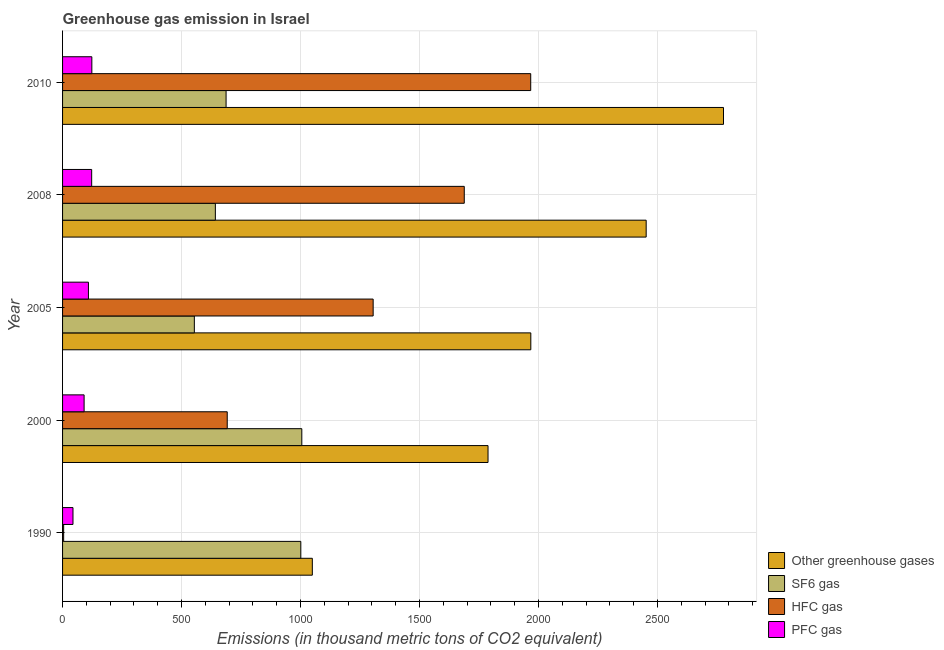Are the number of bars per tick equal to the number of legend labels?
Make the answer very short. Yes. How many bars are there on the 3rd tick from the bottom?
Give a very brief answer. 4. What is the label of the 3rd group of bars from the top?
Offer a very short reply. 2005. In how many cases, is the number of bars for a given year not equal to the number of legend labels?
Keep it short and to the point. 0. What is the emission of pfc gas in 2005?
Offer a terse response. 108.7. Across all years, what is the maximum emission of pfc gas?
Your answer should be very brief. 123. Across all years, what is the minimum emission of sf6 gas?
Your response must be concise. 553.7. What is the total emission of greenhouse gases in the graph?
Your answer should be compact. 1.00e+04. What is the difference between the emission of greenhouse gases in 2000 and that in 2010?
Provide a succinct answer. -989.4. What is the difference between the emission of pfc gas in 2010 and the emission of sf6 gas in 2000?
Give a very brief answer. -882.2. What is the average emission of pfc gas per year?
Ensure brevity in your answer.  97.66. In the year 2008, what is the difference between the emission of pfc gas and emission of hfc gas?
Make the answer very short. -1565.5. What is the ratio of the emission of greenhouse gases in 2005 to that in 2010?
Your answer should be very brief. 0.71. Is the emission of pfc gas in 2005 less than that in 2010?
Keep it short and to the point. Yes. Is the difference between the emission of greenhouse gases in 2000 and 2005 greater than the difference between the emission of pfc gas in 2000 and 2005?
Provide a succinct answer. No. What is the difference between the highest and the second highest emission of hfc gas?
Keep it short and to the point. 279.2. What is the difference between the highest and the lowest emission of greenhouse gases?
Give a very brief answer. 1727.6. Is the sum of the emission of hfc gas in 2000 and 2005 greater than the maximum emission of sf6 gas across all years?
Give a very brief answer. Yes. What does the 3rd bar from the top in 2008 represents?
Offer a terse response. SF6 gas. What does the 4th bar from the bottom in 2010 represents?
Give a very brief answer. PFC gas. Is it the case that in every year, the sum of the emission of greenhouse gases and emission of sf6 gas is greater than the emission of hfc gas?
Provide a short and direct response. Yes. Are all the bars in the graph horizontal?
Provide a short and direct response. Yes. What is the difference between two consecutive major ticks on the X-axis?
Give a very brief answer. 500. Does the graph contain any zero values?
Provide a succinct answer. No. Where does the legend appear in the graph?
Provide a short and direct response. Bottom right. What is the title of the graph?
Your answer should be compact. Greenhouse gas emission in Israel. What is the label or title of the X-axis?
Make the answer very short. Emissions (in thousand metric tons of CO2 equivalent). What is the Emissions (in thousand metric tons of CO2 equivalent) of Other greenhouse gases in 1990?
Offer a very short reply. 1049.4. What is the Emissions (in thousand metric tons of CO2 equivalent) in SF6 gas in 1990?
Provide a succinct answer. 1001. What is the Emissions (in thousand metric tons of CO2 equivalent) in PFC gas in 1990?
Ensure brevity in your answer.  43.8. What is the Emissions (in thousand metric tons of CO2 equivalent) of Other greenhouse gases in 2000?
Keep it short and to the point. 1787.6. What is the Emissions (in thousand metric tons of CO2 equivalent) in SF6 gas in 2000?
Provide a short and direct response. 1005.2. What is the Emissions (in thousand metric tons of CO2 equivalent) of HFC gas in 2000?
Your answer should be very brief. 691.9. What is the Emissions (in thousand metric tons of CO2 equivalent) of PFC gas in 2000?
Ensure brevity in your answer.  90.5. What is the Emissions (in thousand metric tons of CO2 equivalent) of Other greenhouse gases in 2005?
Make the answer very short. 1967.4. What is the Emissions (in thousand metric tons of CO2 equivalent) of SF6 gas in 2005?
Your answer should be compact. 553.7. What is the Emissions (in thousand metric tons of CO2 equivalent) of HFC gas in 2005?
Provide a short and direct response. 1305. What is the Emissions (in thousand metric tons of CO2 equivalent) of PFC gas in 2005?
Your response must be concise. 108.7. What is the Emissions (in thousand metric tons of CO2 equivalent) of Other greenhouse gases in 2008?
Your answer should be very brief. 2452.1. What is the Emissions (in thousand metric tons of CO2 equivalent) in SF6 gas in 2008?
Provide a succinct answer. 642. What is the Emissions (in thousand metric tons of CO2 equivalent) of HFC gas in 2008?
Offer a terse response. 1687.8. What is the Emissions (in thousand metric tons of CO2 equivalent) in PFC gas in 2008?
Provide a short and direct response. 122.3. What is the Emissions (in thousand metric tons of CO2 equivalent) in Other greenhouse gases in 2010?
Offer a terse response. 2777. What is the Emissions (in thousand metric tons of CO2 equivalent) of SF6 gas in 2010?
Ensure brevity in your answer.  687. What is the Emissions (in thousand metric tons of CO2 equivalent) of HFC gas in 2010?
Your response must be concise. 1967. What is the Emissions (in thousand metric tons of CO2 equivalent) in PFC gas in 2010?
Provide a short and direct response. 123. Across all years, what is the maximum Emissions (in thousand metric tons of CO2 equivalent) in Other greenhouse gases?
Offer a terse response. 2777. Across all years, what is the maximum Emissions (in thousand metric tons of CO2 equivalent) of SF6 gas?
Make the answer very short. 1005.2. Across all years, what is the maximum Emissions (in thousand metric tons of CO2 equivalent) in HFC gas?
Offer a very short reply. 1967. Across all years, what is the maximum Emissions (in thousand metric tons of CO2 equivalent) of PFC gas?
Provide a succinct answer. 123. Across all years, what is the minimum Emissions (in thousand metric tons of CO2 equivalent) in Other greenhouse gases?
Your answer should be very brief. 1049.4. Across all years, what is the minimum Emissions (in thousand metric tons of CO2 equivalent) in SF6 gas?
Provide a succinct answer. 553.7. Across all years, what is the minimum Emissions (in thousand metric tons of CO2 equivalent) in HFC gas?
Your response must be concise. 4.6. Across all years, what is the minimum Emissions (in thousand metric tons of CO2 equivalent) of PFC gas?
Your response must be concise. 43.8. What is the total Emissions (in thousand metric tons of CO2 equivalent) in Other greenhouse gases in the graph?
Keep it short and to the point. 1.00e+04. What is the total Emissions (in thousand metric tons of CO2 equivalent) of SF6 gas in the graph?
Offer a very short reply. 3888.9. What is the total Emissions (in thousand metric tons of CO2 equivalent) of HFC gas in the graph?
Your answer should be very brief. 5656.3. What is the total Emissions (in thousand metric tons of CO2 equivalent) of PFC gas in the graph?
Your answer should be compact. 488.3. What is the difference between the Emissions (in thousand metric tons of CO2 equivalent) in Other greenhouse gases in 1990 and that in 2000?
Offer a very short reply. -738.2. What is the difference between the Emissions (in thousand metric tons of CO2 equivalent) of SF6 gas in 1990 and that in 2000?
Your response must be concise. -4.2. What is the difference between the Emissions (in thousand metric tons of CO2 equivalent) of HFC gas in 1990 and that in 2000?
Your response must be concise. -687.3. What is the difference between the Emissions (in thousand metric tons of CO2 equivalent) of PFC gas in 1990 and that in 2000?
Provide a succinct answer. -46.7. What is the difference between the Emissions (in thousand metric tons of CO2 equivalent) in Other greenhouse gases in 1990 and that in 2005?
Your response must be concise. -918. What is the difference between the Emissions (in thousand metric tons of CO2 equivalent) in SF6 gas in 1990 and that in 2005?
Offer a terse response. 447.3. What is the difference between the Emissions (in thousand metric tons of CO2 equivalent) in HFC gas in 1990 and that in 2005?
Provide a succinct answer. -1300.4. What is the difference between the Emissions (in thousand metric tons of CO2 equivalent) in PFC gas in 1990 and that in 2005?
Offer a very short reply. -64.9. What is the difference between the Emissions (in thousand metric tons of CO2 equivalent) in Other greenhouse gases in 1990 and that in 2008?
Offer a terse response. -1402.7. What is the difference between the Emissions (in thousand metric tons of CO2 equivalent) of SF6 gas in 1990 and that in 2008?
Provide a short and direct response. 359. What is the difference between the Emissions (in thousand metric tons of CO2 equivalent) in HFC gas in 1990 and that in 2008?
Make the answer very short. -1683.2. What is the difference between the Emissions (in thousand metric tons of CO2 equivalent) of PFC gas in 1990 and that in 2008?
Ensure brevity in your answer.  -78.5. What is the difference between the Emissions (in thousand metric tons of CO2 equivalent) in Other greenhouse gases in 1990 and that in 2010?
Your answer should be very brief. -1727.6. What is the difference between the Emissions (in thousand metric tons of CO2 equivalent) in SF6 gas in 1990 and that in 2010?
Ensure brevity in your answer.  314. What is the difference between the Emissions (in thousand metric tons of CO2 equivalent) of HFC gas in 1990 and that in 2010?
Give a very brief answer. -1962.4. What is the difference between the Emissions (in thousand metric tons of CO2 equivalent) of PFC gas in 1990 and that in 2010?
Your answer should be very brief. -79.2. What is the difference between the Emissions (in thousand metric tons of CO2 equivalent) in Other greenhouse gases in 2000 and that in 2005?
Give a very brief answer. -179.8. What is the difference between the Emissions (in thousand metric tons of CO2 equivalent) of SF6 gas in 2000 and that in 2005?
Your answer should be very brief. 451.5. What is the difference between the Emissions (in thousand metric tons of CO2 equivalent) of HFC gas in 2000 and that in 2005?
Provide a succinct answer. -613.1. What is the difference between the Emissions (in thousand metric tons of CO2 equivalent) of PFC gas in 2000 and that in 2005?
Your answer should be compact. -18.2. What is the difference between the Emissions (in thousand metric tons of CO2 equivalent) of Other greenhouse gases in 2000 and that in 2008?
Offer a terse response. -664.5. What is the difference between the Emissions (in thousand metric tons of CO2 equivalent) of SF6 gas in 2000 and that in 2008?
Give a very brief answer. 363.2. What is the difference between the Emissions (in thousand metric tons of CO2 equivalent) in HFC gas in 2000 and that in 2008?
Ensure brevity in your answer.  -995.9. What is the difference between the Emissions (in thousand metric tons of CO2 equivalent) of PFC gas in 2000 and that in 2008?
Your answer should be very brief. -31.8. What is the difference between the Emissions (in thousand metric tons of CO2 equivalent) of Other greenhouse gases in 2000 and that in 2010?
Keep it short and to the point. -989.4. What is the difference between the Emissions (in thousand metric tons of CO2 equivalent) of SF6 gas in 2000 and that in 2010?
Offer a terse response. 318.2. What is the difference between the Emissions (in thousand metric tons of CO2 equivalent) in HFC gas in 2000 and that in 2010?
Your answer should be compact. -1275.1. What is the difference between the Emissions (in thousand metric tons of CO2 equivalent) in PFC gas in 2000 and that in 2010?
Keep it short and to the point. -32.5. What is the difference between the Emissions (in thousand metric tons of CO2 equivalent) in Other greenhouse gases in 2005 and that in 2008?
Your response must be concise. -484.7. What is the difference between the Emissions (in thousand metric tons of CO2 equivalent) of SF6 gas in 2005 and that in 2008?
Offer a terse response. -88.3. What is the difference between the Emissions (in thousand metric tons of CO2 equivalent) of HFC gas in 2005 and that in 2008?
Your answer should be compact. -382.8. What is the difference between the Emissions (in thousand metric tons of CO2 equivalent) in PFC gas in 2005 and that in 2008?
Your answer should be very brief. -13.6. What is the difference between the Emissions (in thousand metric tons of CO2 equivalent) of Other greenhouse gases in 2005 and that in 2010?
Keep it short and to the point. -809.6. What is the difference between the Emissions (in thousand metric tons of CO2 equivalent) of SF6 gas in 2005 and that in 2010?
Your answer should be very brief. -133.3. What is the difference between the Emissions (in thousand metric tons of CO2 equivalent) of HFC gas in 2005 and that in 2010?
Provide a short and direct response. -662. What is the difference between the Emissions (in thousand metric tons of CO2 equivalent) in PFC gas in 2005 and that in 2010?
Offer a terse response. -14.3. What is the difference between the Emissions (in thousand metric tons of CO2 equivalent) of Other greenhouse gases in 2008 and that in 2010?
Ensure brevity in your answer.  -324.9. What is the difference between the Emissions (in thousand metric tons of CO2 equivalent) of SF6 gas in 2008 and that in 2010?
Provide a short and direct response. -45. What is the difference between the Emissions (in thousand metric tons of CO2 equivalent) of HFC gas in 2008 and that in 2010?
Ensure brevity in your answer.  -279.2. What is the difference between the Emissions (in thousand metric tons of CO2 equivalent) in Other greenhouse gases in 1990 and the Emissions (in thousand metric tons of CO2 equivalent) in SF6 gas in 2000?
Your response must be concise. 44.2. What is the difference between the Emissions (in thousand metric tons of CO2 equivalent) of Other greenhouse gases in 1990 and the Emissions (in thousand metric tons of CO2 equivalent) of HFC gas in 2000?
Your answer should be compact. 357.5. What is the difference between the Emissions (in thousand metric tons of CO2 equivalent) of Other greenhouse gases in 1990 and the Emissions (in thousand metric tons of CO2 equivalent) of PFC gas in 2000?
Your response must be concise. 958.9. What is the difference between the Emissions (in thousand metric tons of CO2 equivalent) in SF6 gas in 1990 and the Emissions (in thousand metric tons of CO2 equivalent) in HFC gas in 2000?
Your response must be concise. 309.1. What is the difference between the Emissions (in thousand metric tons of CO2 equivalent) in SF6 gas in 1990 and the Emissions (in thousand metric tons of CO2 equivalent) in PFC gas in 2000?
Provide a succinct answer. 910.5. What is the difference between the Emissions (in thousand metric tons of CO2 equivalent) of HFC gas in 1990 and the Emissions (in thousand metric tons of CO2 equivalent) of PFC gas in 2000?
Offer a terse response. -85.9. What is the difference between the Emissions (in thousand metric tons of CO2 equivalent) in Other greenhouse gases in 1990 and the Emissions (in thousand metric tons of CO2 equivalent) in SF6 gas in 2005?
Your answer should be compact. 495.7. What is the difference between the Emissions (in thousand metric tons of CO2 equivalent) in Other greenhouse gases in 1990 and the Emissions (in thousand metric tons of CO2 equivalent) in HFC gas in 2005?
Make the answer very short. -255.6. What is the difference between the Emissions (in thousand metric tons of CO2 equivalent) in Other greenhouse gases in 1990 and the Emissions (in thousand metric tons of CO2 equivalent) in PFC gas in 2005?
Ensure brevity in your answer.  940.7. What is the difference between the Emissions (in thousand metric tons of CO2 equivalent) in SF6 gas in 1990 and the Emissions (in thousand metric tons of CO2 equivalent) in HFC gas in 2005?
Provide a short and direct response. -304. What is the difference between the Emissions (in thousand metric tons of CO2 equivalent) of SF6 gas in 1990 and the Emissions (in thousand metric tons of CO2 equivalent) of PFC gas in 2005?
Keep it short and to the point. 892.3. What is the difference between the Emissions (in thousand metric tons of CO2 equivalent) of HFC gas in 1990 and the Emissions (in thousand metric tons of CO2 equivalent) of PFC gas in 2005?
Keep it short and to the point. -104.1. What is the difference between the Emissions (in thousand metric tons of CO2 equivalent) in Other greenhouse gases in 1990 and the Emissions (in thousand metric tons of CO2 equivalent) in SF6 gas in 2008?
Give a very brief answer. 407.4. What is the difference between the Emissions (in thousand metric tons of CO2 equivalent) in Other greenhouse gases in 1990 and the Emissions (in thousand metric tons of CO2 equivalent) in HFC gas in 2008?
Offer a terse response. -638.4. What is the difference between the Emissions (in thousand metric tons of CO2 equivalent) of Other greenhouse gases in 1990 and the Emissions (in thousand metric tons of CO2 equivalent) of PFC gas in 2008?
Keep it short and to the point. 927.1. What is the difference between the Emissions (in thousand metric tons of CO2 equivalent) of SF6 gas in 1990 and the Emissions (in thousand metric tons of CO2 equivalent) of HFC gas in 2008?
Provide a succinct answer. -686.8. What is the difference between the Emissions (in thousand metric tons of CO2 equivalent) in SF6 gas in 1990 and the Emissions (in thousand metric tons of CO2 equivalent) in PFC gas in 2008?
Provide a succinct answer. 878.7. What is the difference between the Emissions (in thousand metric tons of CO2 equivalent) in HFC gas in 1990 and the Emissions (in thousand metric tons of CO2 equivalent) in PFC gas in 2008?
Ensure brevity in your answer.  -117.7. What is the difference between the Emissions (in thousand metric tons of CO2 equivalent) in Other greenhouse gases in 1990 and the Emissions (in thousand metric tons of CO2 equivalent) in SF6 gas in 2010?
Offer a very short reply. 362.4. What is the difference between the Emissions (in thousand metric tons of CO2 equivalent) of Other greenhouse gases in 1990 and the Emissions (in thousand metric tons of CO2 equivalent) of HFC gas in 2010?
Make the answer very short. -917.6. What is the difference between the Emissions (in thousand metric tons of CO2 equivalent) in Other greenhouse gases in 1990 and the Emissions (in thousand metric tons of CO2 equivalent) in PFC gas in 2010?
Make the answer very short. 926.4. What is the difference between the Emissions (in thousand metric tons of CO2 equivalent) of SF6 gas in 1990 and the Emissions (in thousand metric tons of CO2 equivalent) of HFC gas in 2010?
Give a very brief answer. -966. What is the difference between the Emissions (in thousand metric tons of CO2 equivalent) of SF6 gas in 1990 and the Emissions (in thousand metric tons of CO2 equivalent) of PFC gas in 2010?
Offer a very short reply. 878. What is the difference between the Emissions (in thousand metric tons of CO2 equivalent) of HFC gas in 1990 and the Emissions (in thousand metric tons of CO2 equivalent) of PFC gas in 2010?
Ensure brevity in your answer.  -118.4. What is the difference between the Emissions (in thousand metric tons of CO2 equivalent) of Other greenhouse gases in 2000 and the Emissions (in thousand metric tons of CO2 equivalent) of SF6 gas in 2005?
Provide a succinct answer. 1233.9. What is the difference between the Emissions (in thousand metric tons of CO2 equivalent) of Other greenhouse gases in 2000 and the Emissions (in thousand metric tons of CO2 equivalent) of HFC gas in 2005?
Make the answer very short. 482.6. What is the difference between the Emissions (in thousand metric tons of CO2 equivalent) in Other greenhouse gases in 2000 and the Emissions (in thousand metric tons of CO2 equivalent) in PFC gas in 2005?
Ensure brevity in your answer.  1678.9. What is the difference between the Emissions (in thousand metric tons of CO2 equivalent) in SF6 gas in 2000 and the Emissions (in thousand metric tons of CO2 equivalent) in HFC gas in 2005?
Make the answer very short. -299.8. What is the difference between the Emissions (in thousand metric tons of CO2 equivalent) in SF6 gas in 2000 and the Emissions (in thousand metric tons of CO2 equivalent) in PFC gas in 2005?
Keep it short and to the point. 896.5. What is the difference between the Emissions (in thousand metric tons of CO2 equivalent) in HFC gas in 2000 and the Emissions (in thousand metric tons of CO2 equivalent) in PFC gas in 2005?
Your response must be concise. 583.2. What is the difference between the Emissions (in thousand metric tons of CO2 equivalent) of Other greenhouse gases in 2000 and the Emissions (in thousand metric tons of CO2 equivalent) of SF6 gas in 2008?
Offer a terse response. 1145.6. What is the difference between the Emissions (in thousand metric tons of CO2 equivalent) of Other greenhouse gases in 2000 and the Emissions (in thousand metric tons of CO2 equivalent) of HFC gas in 2008?
Give a very brief answer. 99.8. What is the difference between the Emissions (in thousand metric tons of CO2 equivalent) in Other greenhouse gases in 2000 and the Emissions (in thousand metric tons of CO2 equivalent) in PFC gas in 2008?
Offer a terse response. 1665.3. What is the difference between the Emissions (in thousand metric tons of CO2 equivalent) of SF6 gas in 2000 and the Emissions (in thousand metric tons of CO2 equivalent) of HFC gas in 2008?
Your answer should be very brief. -682.6. What is the difference between the Emissions (in thousand metric tons of CO2 equivalent) of SF6 gas in 2000 and the Emissions (in thousand metric tons of CO2 equivalent) of PFC gas in 2008?
Your answer should be compact. 882.9. What is the difference between the Emissions (in thousand metric tons of CO2 equivalent) of HFC gas in 2000 and the Emissions (in thousand metric tons of CO2 equivalent) of PFC gas in 2008?
Provide a succinct answer. 569.6. What is the difference between the Emissions (in thousand metric tons of CO2 equivalent) of Other greenhouse gases in 2000 and the Emissions (in thousand metric tons of CO2 equivalent) of SF6 gas in 2010?
Offer a very short reply. 1100.6. What is the difference between the Emissions (in thousand metric tons of CO2 equivalent) in Other greenhouse gases in 2000 and the Emissions (in thousand metric tons of CO2 equivalent) in HFC gas in 2010?
Make the answer very short. -179.4. What is the difference between the Emissions (in thousand metric tons of CO2 equivalent) of Other greenhouse gases in 2000 and the Emissions (in thousand metric tons of CO2 equivalent) of PFC gas in 2010?
Keep it short and to the point. 1664.6. What is the difference between the Emissions (in thousand metric tons of CO2 equivalent) of SF6 gas in 2000 and the Emissions (in thousand metric tons of CO2 equivalent) of HFC gas in 2010?
Offer a terse response. -961.8. What is the difference between the Emissions (in thousand metric tons of CO2 equivalent) in SF6 gas in 2000 and the Emissions (in thousand metric tons of CO2 equivalent) in PFC gas in 2010?
Offer a terse response. 882.2. What is the difference between the Emissions (in thousand metric tons of CO2 equivalent) in HFC gas in 2000 and the Emissions (in thousand metric tons of CO2 equivalent) in PFC gas in 2010?
Keep it short and to the point. 568.9. What is the difference between the Emissions (in thousand metric tons of CO2 equivalent) of Other greenhouse gases in 2005 and the Emissions (in thousand metric tons of CO2 equivalent) of SF6 gas in 2008?
Provide a succinct answer. 1325.4. What is the difference between the Emissions (in thousand metric tons of CO2 equivalent) of Other greenhouse gases in 2005 and the Emissions (in thousand metric tons of CO2 equivalent) of HFC gas in 2008?
Your answer should be very brief. 279.6. What is the difference between the Emissions (in thousand metric tons of CO2 equivalent) in Other greenhouse gases in 2005 and the Emissions (in thousand metric tons of CO2 equivalent) in PFC gas in 2008?
Offer a very short reply. 1845.1. What is the difference between the Emissions (in thousand metric tons of CO2 equivalent) of SF6 gas in 2005 and the Emissions (in thousand metric tons of CO2 equivalent) of HFC gas in 2008?
Give a very brief answer. -1134.1. What is the difference between the Emissions (in thousand metric tons of CO2 equivalent) in SF6 gas in 2005 and the Emissions (in thousand metric tons of CO2 equivalent) in PFC gas in 2008?
Provide a succinct answer. 431.4. What is the difference between the Emissions (in thousand metric tons of CO2 equivalent) in HFC gas in 2005 and the Emissions (in thousand metric tons of CO2 equivalent) in PFC gas in 2008?
Your answer should be compact. 1182.7. What is the difference between the Emissions (in thousand metric tons of CO2 equivalent) of Other greenhouse gases in 2005 and the Emissions (in thousand metric tons of CO2 equivalent) of SF6 gas in 2010?
Provide a succinct answer. 1280.4. What is the difference between the Emissions (in thousand metric tons of CO2 equivalent) of Other greenhouse gases in 2005 and the Emissions (in thousand metric tons of CO2 equivalent) of HFC gas in 2010?
Give a very brief answer. 0.4. What is the difference between the Emissions (in thousand metric tons of CO2 equivalent) in Other greenhouse gases in 2005 and the Emissions (in thousand metric tons of CO2 equivalent) in PFC gas in 2010?
Your response must be concise. 1844.4. What is the difference between the Emissions (in thousand metric tons of CO2 equivalent) in SF6 gas in 2005 and the Emissions (in thousand metric tons of CO2 equivalent) in HFC gas in 2010?
Make the answer very short. -1413.3. What is the difference between the Emissions (in thousand metric tons of CO2 equivalent) in SF6 gas in 2005 and the Emissions (in thousand metric tons of CO2 equivalent) in PFC gas in 2010?
Keep it short and to the point. 430.7. What is the difference between the Emissions (in thousand metric tons of CO2 equivalent) of HFC gas in 2005 and the Emissions (in thousand metric tons of CO2 equivalent) of PFC gas in 2010?
Your answer should be compact. 1182. What is the difference between the Emissions (in thousand metric tons of CO2 equivalent) in Other greenhouse gases in 2008 and the Emissions (in thousand metric tons of CO2 equivalent) in SF6 gas in 2010?
Offer a very short reply. 1765.1. What is the difference between the Emissions (in thousand metric tons of CO2 equivalent) of Other greenhouse gases in 2008 and the Emissions (in thousand metric tons of CO2 equivalent) of HFC gas in 2010?
Give a very brief answer. 485.1. What is the difference between the Emissions (in thousand metric tons of CO2 equivalent) of Other greenhouse gases in 2008 and the Emissions (in thousand metric tons of CO2 equivalent) of PFC gas in 2010?
Offer a terse response. 2329.1. What is the difference between the Emissions (in thousand metric tons of CO2 equivalent) of SF6 gas in 2008 and the Emissions (in thousand metric tons of CO2 equivalent) of HFC gas in 2010?
Your response must be concise. -1325. What is the difference between the Emissions (in thousand metric tons of CO2 equivalent) in SF6 gas in 2008 and the Emissions (in thousand metric tons of CO2 equivalent) in PFC gas in 2010?
Ensure brevity in your answer.  519. What is the difference between the Emissions (in thousand metric tons of CO2 equivalent) of HFC gas in 2008 and the Emissions (in thousand metric tons of CO2 equivalent) of PFC gas in 2010?
Provide a short and direct response. 1564.8. What is the average Emissions (in thousand metric tons of CO2 equivalent) of Other greenhouse gases per year?
Offer a terse response. 2006.7. What is the average Emissions (in thousand metric tons of CO2 equivalent) of SF6 gas per year?
Ensure brevity in your answer.  777.78. What is the average Emissions (in thousand metric tons of CO2 equivalent) in HFC gas per year?
Your response must be concise. 1131.26. What is the average Emissions (in thousand metric tons of CO2 equivalent) in PFC gas per year?
Your answer should be very brief. 97.66. In the year 1990, what is the difference between the Emissions (in thousand metric tons of CO2 equivalent) in Other greenhouse gases and Emissions (in thousand metric tons of CO2 equivalent) in SF6 gas?
Keep it short and to the point. 48.4. In the year 1990, what is the difference between the Emissions (in thousand metric tons of CO2 equivalent) in Other greenhouse gases and Emissions (in thousand metric tons of CO2 equivalent) in HFC gas?
Ensure brevity in your answer.  1044.8. In the year 1990, what is the difference between the Emissions (in thousand metric tons of CO2 equivalent) of Other greenhouse gases and Emissions (in thousand metric tons of CO2 equivalent) of PFC gas?
Provide a short and direct response. 1005.6. In the year 1990, what is the difference between the Emissions (in thousand metric tons of CO2 equivalent) in SF6 gas and Emissions (in thousand metric tons of CO2 equivalent) in HFC gas?
Provide a short and direct response. 996.4. In the year 1990, what is the difference between the Emissions (in thousand metric tons of CO2 equivalent) in SF6 gas and Emissions (in thousand metric tons of CO2 equivalent) in PFC gas?
Your answer should be very brief. 957.2. In the year 1990, what is the difference between the Emissions (in thousand metric tons of CO2 equivalent) in HFC gas and Emissions (in thousand metric tons of CO2 equivalent) in PFC gas?
Provide a short and direct response. -39.2. In the year 2000, what is the difference between the Emissions (in thousand metric tons of CO2 equivalent) in Other greenhouse gases and Emissions (in thousand metric tons of CO2 equivalent) in SF6 gas?
Your answer should be compact. 782.4. In the year 2000, what is the difference between the Emissions (in thousand metric tons of CO2 equivalent) of Other greenhouse gases and Emissions (in thousand metric tons of CO2 equivalent) of HFC gas?
Your response must be concise. 1095.7. In the year 2000, what is the difference between the Emissions (in thousand metric tons of CO2 equivalent) in Other greenhouse gases and Emissions (in thousand metric tons of CO2 equivalent) in PFC gas?
Ensure brevity in your answer.  1697.1. In the year 2000, what is the difference between the Emissions (in thousand metric tons of CO2 equivalent) of SF6 gas and Emissions (in thousand metric tons of CO2 equivalent) of HFC gas?
Provide a succinct answer. 313.3. In the year 2000, what is the difference between the Emissions (in thousand metric tons of CO2 equivalent) of SF6 gas and Emissions (in thousand metric tons of CO2 equivalent) of PFC gas?
Your answer should be very brief. 914.7. In the year 2000, what is the difference between the Emissions (in thousand metric tons of CO2 equivalent) in HFC gas and Emissions (in thousand metric tons of CO2 equivalent) in PFC gas?
Provide a short and direct response. 601.4. In the year 2005, what is the difference between the Emissions (in thousand metric tons of CO2 equivalent) of Other greenhouse gases and Emissions (in thousand metric tons of CO2 equivalent) of SF6 gas?
Your response must be concise. 1413.7. In the year 2005, what is the difference between the Emissions (in thousand metric tons of CO2 equivalent) of Other greenhouse gases and Emissions (in thousand metric tons of CO2 equivalent) of HFC gas?
Your answer should be very brief. 662.4. In the year 2005, what is the difference between the Emissions (in thousand metric tons of CO2 equivalent) in Other greenhouse gases and Emissions (in thousand metric tons of CO2 equivalent) in PFC gas?
Provide a short and direct response. 1858.7. In the year 2005, what is the difference between the Emissions (in thousand metric tons of CO2 equivalent) of SF6 gas and Emissions (in thousand metric tons of CO2 equivalent) of HFC gas?
Provide a short and direct response. -751.3. In the year 2005, what is the difference between the Emissions (in thousand metric tons of CO2 equivalent) in SF6 gas and Emissions (in thousand metric tons of CO2 equivalent) in PFC gas?
Keep it short and to the point. 445. In the year 2005, what is the difference between the Emissions (in thousand metric tons of CO2 equivalent) in HFC gas and Emissions (in thousand metric tons of CO2 equivalent) in PFC gas?
Your response must be concise. 1196.3. In the year 2008, what is the difference between the Emissions (in thousand metric tons of CO2 equivalent) of Other greenhouse gases and Emissions (in thousand metric tons of CO2 equivalent) of SF6 gas?
Your answer should be very brief. 1810.1. In the year 2008, what is the difference between the Emissions (in thousand metric tons of CO2 equivalent) in Other greenhouse gases and Emissions (in thousand metric tons of CO2 equivalent) in HFC gas?
Your answer should be very brief. 764.3. In the year 2008, what is the difference between the Emissions (in thousand metric tons of CO2 equivalent) of Other greenhouse gases and Emissions (in thousand metric tons of CO2 equivalent) of PFC gas?
Provide a succinct answer. 2329.8. In the year 2008, what is the difference between the Emissions (in thousand metric tons of CO2 equivalent) of SF6 gas and Emissions (in thousand metric tons of CO2 equivalent) of HFC gas?
Your answer should be compact. -1045.8. In the year 2008, what is the difference between the Emissions (in thousand metric tons of CO2 equivalent) in SF6 gas and Emissions (in thousand metric tons of CO2 equivalent) in PFC gas?
Your response must be concise. 519.7. In the year 2008, what is the difference between the Emissions (in thousand metric tons of CO2 equivalent) in HFC gas and Emissions (in thousand metric tons of CO2 equivalent) in PFC gas?
Ensure brevity in your answer.  1565.5. In the year 2010, what is the difference between the Emissions (in thousand metric tons of CO2 equivalent) of Other greenhouse gases and Emissions (in thousand metric tons of CO2 equivalent) of SF6 gas?
Provide a short and direct response. 2090. In the year 2010, what is the difference between the Emissions (in thousand metric tons of CO2 equivalent) in Other greenhouse gases and Emissions (in thousand metric tons of CO2 equivalent) in HFC gas?
Your answer should be compact. 810. In the year 2010, what is the difference between the Emissions (in thousand metric tons of CO2 equivalent) in Other greenhouse gases and Emissions (in thousand metric tons of CO2 equivalent) in PFC gas?
Provide a succinct answer. 2654. In the year 2010, what is the difference between the Emissions (in thousand metric tons of CO2 equivalent) of SF6 gas and Emissions (in thousand metric tons of CO2 equivalent) of HFC gas?
Keep it short and to the point. -1280. In the year 2010, what is the difference between the Emissions (in thousand metric tons of CO2 equivalent) of SF6 gas and Emissions (in thousand metric tons of CO2 equivalent) of PFC gas?
Give a very brief answer. 564. In the year 2010, what is the difference between the Emissions (in thousand metric tons of CO2 equivalent) in HFC gas and Emissions (in thousand metric tons of CO2 equivalent) in PFC gas?
Offer a very short reply. 1844. What is the ratio of the Emissions (in thousand metric tons of CO2 equivalent) of Other greenhouse gases in 1990 to that in 2000?
Your answer should be compact. 0.59. What is the ratio of the Emissions (in thousand metric tons of CO2 equivalent) in HFC gas in 1990 to that in 2000?
Your answer should be compact. 0.01. What is the ratio of the Emissions (in thousand metric tons of CO2 equivalent) of PFC gas in 1990 to that in 2000?
Offer a very short reply. 0.48. What is the ratio of the Emissions (in thousand metric tons of CO2 equivalent) in Other greenhouse gases in 1990 to that in 2005?
Your response must be concise. 0.53. What is the ratio of the Emissions (in thousand metric tons of CO2 equivalent) in SF6 gas in 1990 to that in 2005?
Provide a short and direct response. 1.81. What is the ratio of the Emissions (in thousand metric tons of CO2 equivalent) in HFC gas in 1990 to that in 2005?
Offer a terse response. 0. What is the ratio of the Emissions (in thousand metric tons of CO2 equivalent) in PFC gas in 1990 to that in 2005?
Provide a succinct answer. 0.4. What is the ratio of the Emissions (in thousand metric tons of CO2 equivalent) in Other greenhouse gases in 1990 to that in 2008?
Provide a short and direct response. 0.43. What is the ratio of the Emissions (in thousand metric tons of CO2 equivalent) in SF6 gas in 1990 to that in 2008?
Your answer should be compact. 1.56. What is the ratio of the Emissions (in thousand metric tons of CO2 equivalent) of HFC gas in 1990 to that in 2008?
Offer a very short reply. 0. What is the ratio of the Emissions (in thousand metric tons of CO2 equivalent) in PFC gas in 1990 to that in 2008?
Make the answer very short. 0.36. What is the ratio of the Emissions (in thousand metric tons of CO2 equivalent) of Other greenhouse gases in 1990 to that in 2010?
Keep it short and to the point. 0.38. What is the ratio of the Emissions (in thousand metric tons of CO2 equivalent) of SF6 gas in 1990 to that in 2010?
Offer a very short reply. 1.46. What is the ratio of the Emissions (in thousand metric tons of CO2 equivalent) in HFC gas in 1990 to that in 2010?
Your answer should be compact. 0. What is the ratio of the Emissions (in thousand metric tons of CO2 equivalent) in PFC gas in 1990 to that in 2010?
Offer a very short reply. 0.36. What is the ratio of the Emissions (in thousand metric tons of CO2 equivalent) of Other greenhouse gases in 2000 to that in 2005?
Make the answer very short. 0.91. What is the ratio of the Emissions (in thousand metric tons of CO2 equivalent) of SF6 gas in 2000 to that in 2005?
Make the answer very short. 1.82. What is the ratio of the Emissions (in thousand metric tons of CO2 equivalent) in HFC gas in 2000 to that in 2005?
Provide a short and direct response. 0.53. What is the ratio of the Emissions (in thousand metric tons of CO2 equivalent) in PFC gas in 2000 to that in 2005?
Your answer should be very brief. 0.83. What is the ratio of the Emissions (in thousand metric tons of CO2 equivalent) of Other greenhouse gases in 2000 to that in 2008?
Your answer should be very brief. 0.73. What is the ratio of the Emissions (in thousand metric tons of CO2 equivalent) in SF6 gas in 2000 to that in 2008?
Offer a very short reply. 1.57. What is the ratio of the Emissions (in thousand metric tons of CO2 equivalent) of HFC gas in 2000 to that in 2008?
Keep it short and to the point. 0.41. What is the ratio of the Emissions (in thousand metric tons of CO2 equivalent) in PFC gas in 2000 to that in 2008?
Make the answer very short. 0.74. What is the ratio of the Emissions (in thousand metric tons of CO2 equivalent) of Other greenhouse gases in 2000 to that in 2010?
Ensure brevity in your answer.  0.64. What is the ratio of the Emissions (in thousand metric tons of CO2 equivalent) in SF6 gas in 2000 to that in 2010?
Provide a succinct answer. 1.46. What is the ratio of the Emissions (in thousand metric tons of CO2 equivalent) of HFC gas in 2000 to that in 2010?
Give a very brief answer. 0.35. What is the ratio of the Emissions (in thousand metric tons of CO2 equivalent) in PFC gas in 2000 to that in 2010?
Keep it short and to the point. 0.74. What is the ratio of the Emissions (in thousand metric tons of CO2 equivalent) of Other greenhouse gases in 2005 to that in 2008?
Offer a very short reply. 0.8. What is the ratio of the Emissions (in thousand metric tons of CO2 equivalent) in SF6 gas in 2005 to that in 2008?
Offer a terse response. 0.86. What is the ratio of the Emissions (in thousand metric tons of CO2 equivalent) of HFC gas in 2005 to that in 2008?
Your answer should be compact. 0.77. What is the ratio of the Emissions (in thousand metric tons of CO2 equivalent) of PFC gas in 2005 to that in 2008?
Offer a very short reply. 0.89. What is the ratio of the Emissions (in thousand metric tons of CO2 equivalent) in Other greenhouse gases in 2005 to that in 2010?
Provide a short and direct response. 0.71. What is the ratio of the Emissions (in thousand metric tons of CO2 equivalent) of SF6 gas in 2005 to that in 2010?
Provide a succinct answer. 0.81. What is the ratio of the Emissions (in thousand metric tons of CO2 equivalent) of HFC gas in 2005 to that in 2010?
Offer a terse response. 0.66. What is the ratio of the Emissions (in thousand metric tons of CO2 equivalent) of PFC gas in 2005 to that in 2010?
Provide a succinct answer. 0.88. What is the ratio of the Emissions (in thousand metric tons of CO2 equivalent) of Other greenhouse gases in 2008 to that in 2010?
Your answer should be compact. 0.88. What is the ratio of the Emissions (in thousand metric tons of CO2 equivalent) in SF6 gas in 2008 to that in 2010?
Your response must be concise. 0.93. What is the ratio of the Emissions (in thousand metric tons of CO2 equivalent) of HFC gas in 2008 to that in 2010?
Offer a very short reply. 0.86. What is the difference between the highest and the second highest Emissions (in thousand metric tons of CO2 equivalent) of Other greenhouse gases?
Provide a succinct answer. 324.9. What is the difference between the highest and the second highest Emissions (in thousand metric tons of CO2 equivalent) of HFC gas?
Your answer should be compact. 279.2. What is the difference between the highest and the second highest Emissions (in thousand metric tons of CO2 equivalent) of PFC gas?
Make the answer very short. 0.7. What is the difference between the highest and the lowest Emissions (in thousand metric tons of CO2 equivalent) of Other greenhouse gases?
Ensure brevity in your answer.  1727.6. What is the difference between the highest and the lowest Emissions (in thousand metric tons of CO2 equivalent) in SF6 gas?
Your answer should be compact. 451.5. What is the difference between the highest and the lowest Emissions (in thousand metric tons of CO2 equivalent) in HFC gas?
Your answer should be compact. 1962.4. What is the difference between the highest and the lowest Emissions (in thousand metric tons of CO2 equivalent) in PFC gas?
Provide a short and direct response. 79.2. 